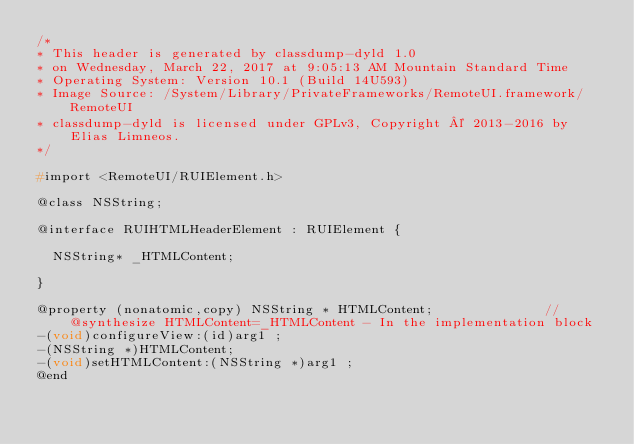Convert code to text. <code><loc_0><loc_0><loc_500><loc_500><_C_>/*
* This header is generated by classdump-dyld 1.0
* on Wednesday, March 22, 2017 at 9:05:13 AM Mountain Standard Time
* Operating System: Version 10.1 (Build 14U593)
* Image Source: /System/Library/PrivateFrameworks/RemoteUI.framework/RemoteUI
* classdump-dyld is licensed under GPLv3, Copyright © 2013-2016 by Elias Limneos.
*/

#import <RemoteUI/RUIElement.h>

@class NSString;

@interface RUIHTMLHeaderElement : RUIElement {

	NSString* _HTMLContent;

}

@property (nonatomic,copy) NSString * HTMLContent;              //@synthesize HTMLContent=_HTMLContent - In the implementation block
-(void)configureView:(id)arg1 ;
-(NSString *)HTMLContent;
-(void)setHTMLContent:(NSString *)arg1 ;
@end

</code> 